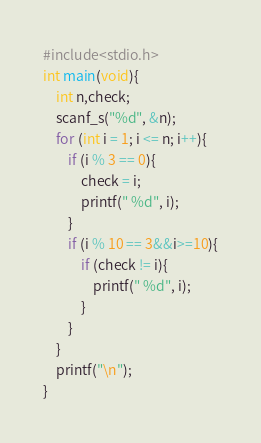<code> <loc_0><loc_0><loc_500><loc_500><_C_>#include<stdio.h>
int main(void){
	int n,check;
	scanf_s("%d", &n);
	for (int i = 1; i <= n; i++){
		if (i % 3 == 0){
			check = i;
			printf(" %d", i);
		}
		if (i % 10 == 3&&i>=10){
			if (check != i){
				printf(" %d", i);
			}
		}
	}
	printf("\n");
}</code> 